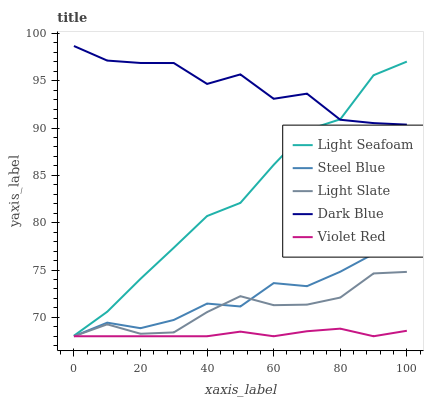Does Violet Red have the minimum area under the curve?
Answer yes or no. Yes. Does Dark Blue have the maximum area under the curve?
Answer yes or no. Yes. Does Dark Blue have the minimum area under the curve?
Answer yes or no. No. Does Violet Red have the maximum area under the curve?
Answer yes or no. No. Is Violet Red the smoothest?
Answer yes or no. Yes. Is Dark Blue the roughest?
Answer yes or no. Yes. Is Dark Blue the smoothest?
Answer yes or no. No. Is Violet Red the roughest?
Answer yes or no. No. Does Light Slate have the lowest value?
Answer yes or no. Yes. Does Dark Blue have the lowest value?
Answer yes or no. No. Does Dark Blue have the highest value?
Answer yes or no. Yes. Does Violet Red have the highest value?
Answer yes or no. No. Is Violet Red less than Dark Blue?
Answer yes or no. Yes. Is Light Seafoam greater than Violet Red?
Answer yes or no. Yes. Does Steel Blue intersect Light Slate?
Answer yes or no. Yes. Is Steel Blue less than Light Slate?
Answer yes or no. No. Is Steel Blue greater than Light Slate?
Answer yes or no. No. Does Violet Red intersect Dark Blue?
Answer yes or no. No. 